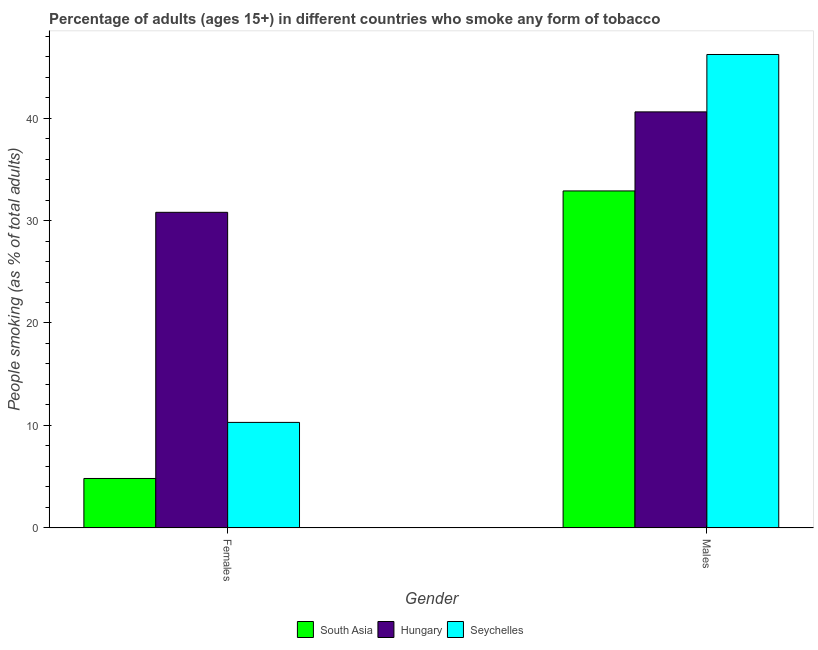How many different coloured bars are there?
Provide a succinct answer. 3. How many groups of bars are there?
Your answer should be compact. 2. Are the number of bars per tick equal to the number of legend labels?
Ensure brevity in your answer.  Yes. Are the number of bars on each tick of the X-axis equal?
Keep it short and to the point. Yes. How many bars are there on the 1st tick from the right?
Provide a succinct answer. 3. What is the label of the 1st group of bars from the left?
Your answer should be very brief. Females. What is the percentage of females who smoke in South Asia?
Your answer should be very brief. 4.83. Across all countries, what is the maximum percentage of females who smoke?
Keep it short and to the point. 30.8. Across all countries, what is the minimum percentage of males who smoke?
Provide a succinct answer. 32.89. In which country was the percentage of females who smoke maximum?
Make the answer very short. Hungary. In which country was the percentage of males who smoke minimum?
Give a very brief answer. South Asia. What is the total percentage of males who smoke in the graph?
Offer a very short reply. 119.69. What is the difference between the percentage of males who smoke in Hungary and that in South Asia?
Provide a short and direct response. 7.71. What is the difference between the percentage of females who smoke in South Asia and the percentage of males who smoke in Seychelles?
Ensure brevity in your answer.  -41.37. What is the average percentage of females who smoke per country?
Make the answer very short. 15.31. What is the difference between the percentage of males who smoke and percentage of females who smoke in Seychelles?
Your response must be concise. 35.9. In how many countries, is the percentage of females who smoke greater than 42 %?
Provide a short and direct response. 0. What is the ratio of the percentage of males who smoke in Seychelles to that in South Asia?
Your response must be concise. 1.4. Is the percentage of females who smoke in Hungary less than that in Seychelles?
Your response must be concise. No. What does the 2nd bar from the left in Males represents?
Keep it short and to the point. Hungary. What does the 3rd bar from the right in Females represents?
Your answer should be compact. South Asia. Are all the bars in the graph horizontal?
Give a very brief answer. No. Are the values on the major ticks of Y-axis written in scientific E-notation?
Provide a short and direct response. No. How many legend labels are there?
Give a very brief answer. 3. How are the legend labels stacked?
Offer a very short reply. Horizontal. What is the title of the graph?
Keep it short and to the point. Percentage of adults (ages 15+) in different countries who smoke any form of tobacco. Does "Liechtenstein" appear as one of the legend labels in the graph?
Ensure brevity in your answer.  No. What is the label or title of the Y-axis?
Ensure brevity in your answer.  People smoking (as % of total adults). What is the People smoking (as % of total adults) in South Asia in Females?
Offer a very short reply. 4.83. What is the People smoking (as % of total adults) of Hungary in Females?
Keep it short and to the point. 30.8. What is the People smoking (as % of total adults) of South Asia in Males?
Ensure brevity in your answer.  32.89. What is the People smoking (as % of total adults) in Hungary in Males?
Your answer should be very brief. 40.6. What is the People smoking (as % of total adults) of Seychelles in Males?
Your response must be concise. 46.2. Across all Gender, what is the maximum People smoking (as % of total adults) in South Asia?
Make the answer very short. 32.89. Across all Gender, what is the maximum People smoking (as % of total adults) in Hungary?
Ensure brevity in your answer.  40.6. Across all Gender, what is the maximum People smoking (as % of total adults) in Seychelles?
Your answer should be compact. 46.2. Across all Gender, what is the minimum People smoking (as % of total adults) of South Asia?
Keep it short and to the point. 4.83. Across all Gender, what is the minimum People smoking (as % of total adults) of Hungary?
Your answer should be very brief. 30.8. Across all Gender, what is the minimum People smoking (as % of total adults) of Seychelles?
Give a very brief answer. 10.3. What is the total People smoking (as % of total adults) in South Asia in the graph?
Offer a terse response. 37.72. What is the total People smoking (as % of total adults) in Hungary in the graph?
Your answer should be compact. 71.4. What is the total People smoking (as % of total adults) in Seychelles in the graph?
Your answer should be very brief. 56.5. What is the difference between the People smoking (as % of total adults) of South Asia in Females and that in Males?
Your answer should be very brief. -28.06. What is the difference between the People smoking (as % of total adults) of Hungary in Females and that in Males?
Ensure brevity in your answer.  -9.8. What is the difference between the People smoking (as % of total adults) of Seychelles in Females and that in Males?
Offer a very short reply. -35.9. What is the difference between the People smoking (as % of total adults) of South Asia in Females and the People smoking (as % of total adults) of Hungary in Males?
Ensure brevity in your answer.  -35.77. What is the difference between the People smoking (as % of total adults) of South Asia in Females and the People smoking (as % of total adults) of Seychelles in Males?
Provide a short and direct response. -41.37. What is the difference between the People smoking (as % of total adults) in Hungary in Females and the People smoking (as % of total adults) in Seychelles in Males?
Your answer should be compact. -15.4. What is the average People smoking (as % of total adults) of South Asia per Gender?
Your response must be concise. 18.86. What is the average People smoking (as % of total adults) in Hungary per Gender?
Keep it short and to the point. 35.7. What is the average People smoking (as % of total adults) in Seychelles per Gender?
Provide a short and direct response. 28.25. What is the difference between the People smoking (as % of total adults) in South Asia and People smoking (as % of total adults) in Hungary in Females?
Your answer should be very brief. -25.97. What is the difference between the People smoking (as % of total adults) of South Asia and People smoking (as % of total adults) of Seychelles in Females?
Provide a succinct answer. -5.47. What is the difference between the People smoking (as % of total adults) in South Asia and People smoking (as % of total adults) in Hungary in Males?
Your response must be concise. -7.71. What is the difference between the People smoking (as % of total adults) of South Asia and People smoking (as % of total adults) of Seychelles in Males?
Your answer should be compact. -13.31. What is the ratio of the People smoking (as % of total adults) of South Asia in Females to that in Males?
Your response must be concise. 0.15. What is the ratio of the People smoking (as % of total adults) of Hungary in Females to that in Males?
Offer a very short reply. 0.76. What is the ratio of the People smoking (as % of total adults) in Seychelles in Females to that in Males?
Give a very brief answer. 0.22. What is the difference between the highest and the second highest People smoking (as % of total adults) of South Asia?
Give a very brief answer. 28.06. What is the difference between the highest and the second highest People smoking (as % of total adults) in Hungary?
Keep it short and to the point. 9.8. What is the difference between the highest and the second highest People smoking (as % of total adults) of Seychelles?
Your answer should be compact. 35.9. What is the difference between the highest and the lowest People smoking (as % of total adults) of South Asia?
Your response must be concise. 28.06. What is the difference between the highest and the lowest People smoking (as % of total adults) in Seychelles?
Ensure brevity in your answer.  35.9. 